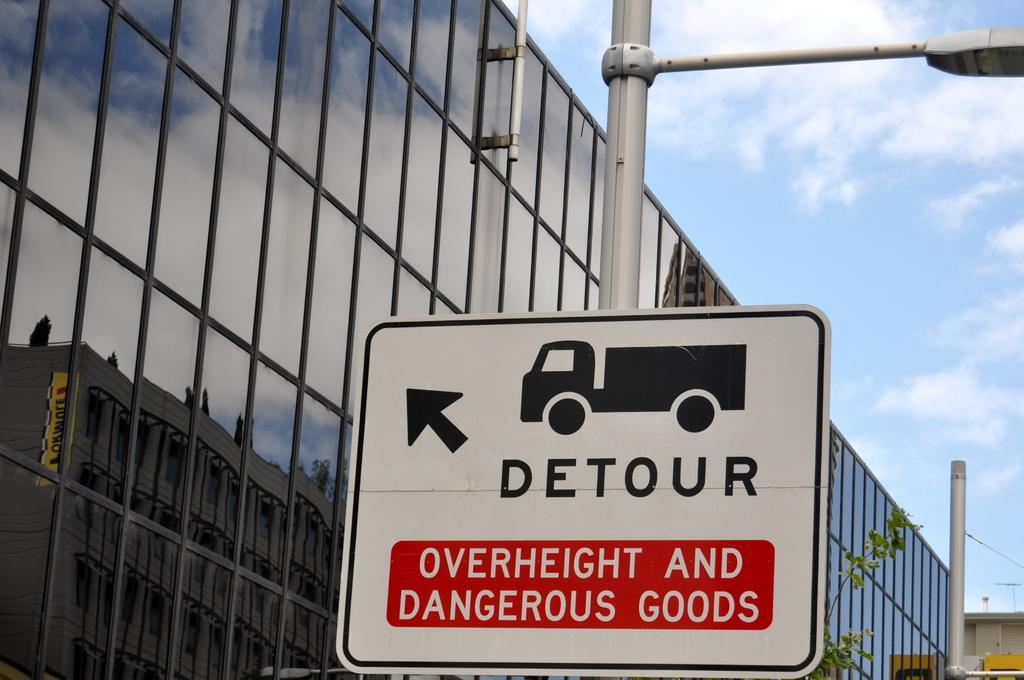<image>
Provide a brief description of the given image. A detour sign points where vehicles that are overly tall or carrying dangerous goods should go. 